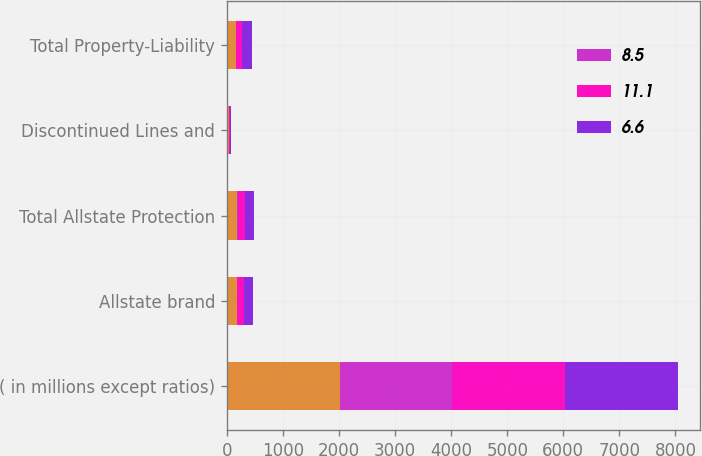<chart> <loc_0><loc_0><loc_500><loc_500><stacked_bar_chart><ecel><fcel>( in millions except ratios)<fcel>Allstate brand<fcel>Total Allstate Protection<fcel>Discontinued Lines and<fcel>Total Property-Liability<nl><fcel>nan<fcel>2010<fcel>181<fcel>187<fcel>28<fcel>159<nl><fcel>8.5<fcel>2010<fcel>0.7<fcel>0.7<fcel>0.1<fcel>0.6<nl><fcel>11.1<fcel>2009<fcel>126<fcel>136<fcel>24<fcel>112<nl><fcel>6.6<fcel>2008<fcel>155<fcel>152<fcel>18<fcel>170<nl></chart> 